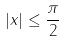<formula> <loc_0><loc_0><loc_500><loc_500>| x | \leq \frac { \pi } { 2 }</formula> 